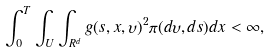<formula> <loc_0><loc_0><loc_500><loc_500>\int _ { 0 } ^ { T } \int _ { U } \int _ { R ^ { d } } g ( s , x , \upsilon ) ^ { 2 } \pi ( d \upsilon , d s ) d x < \infty ,</formula> 